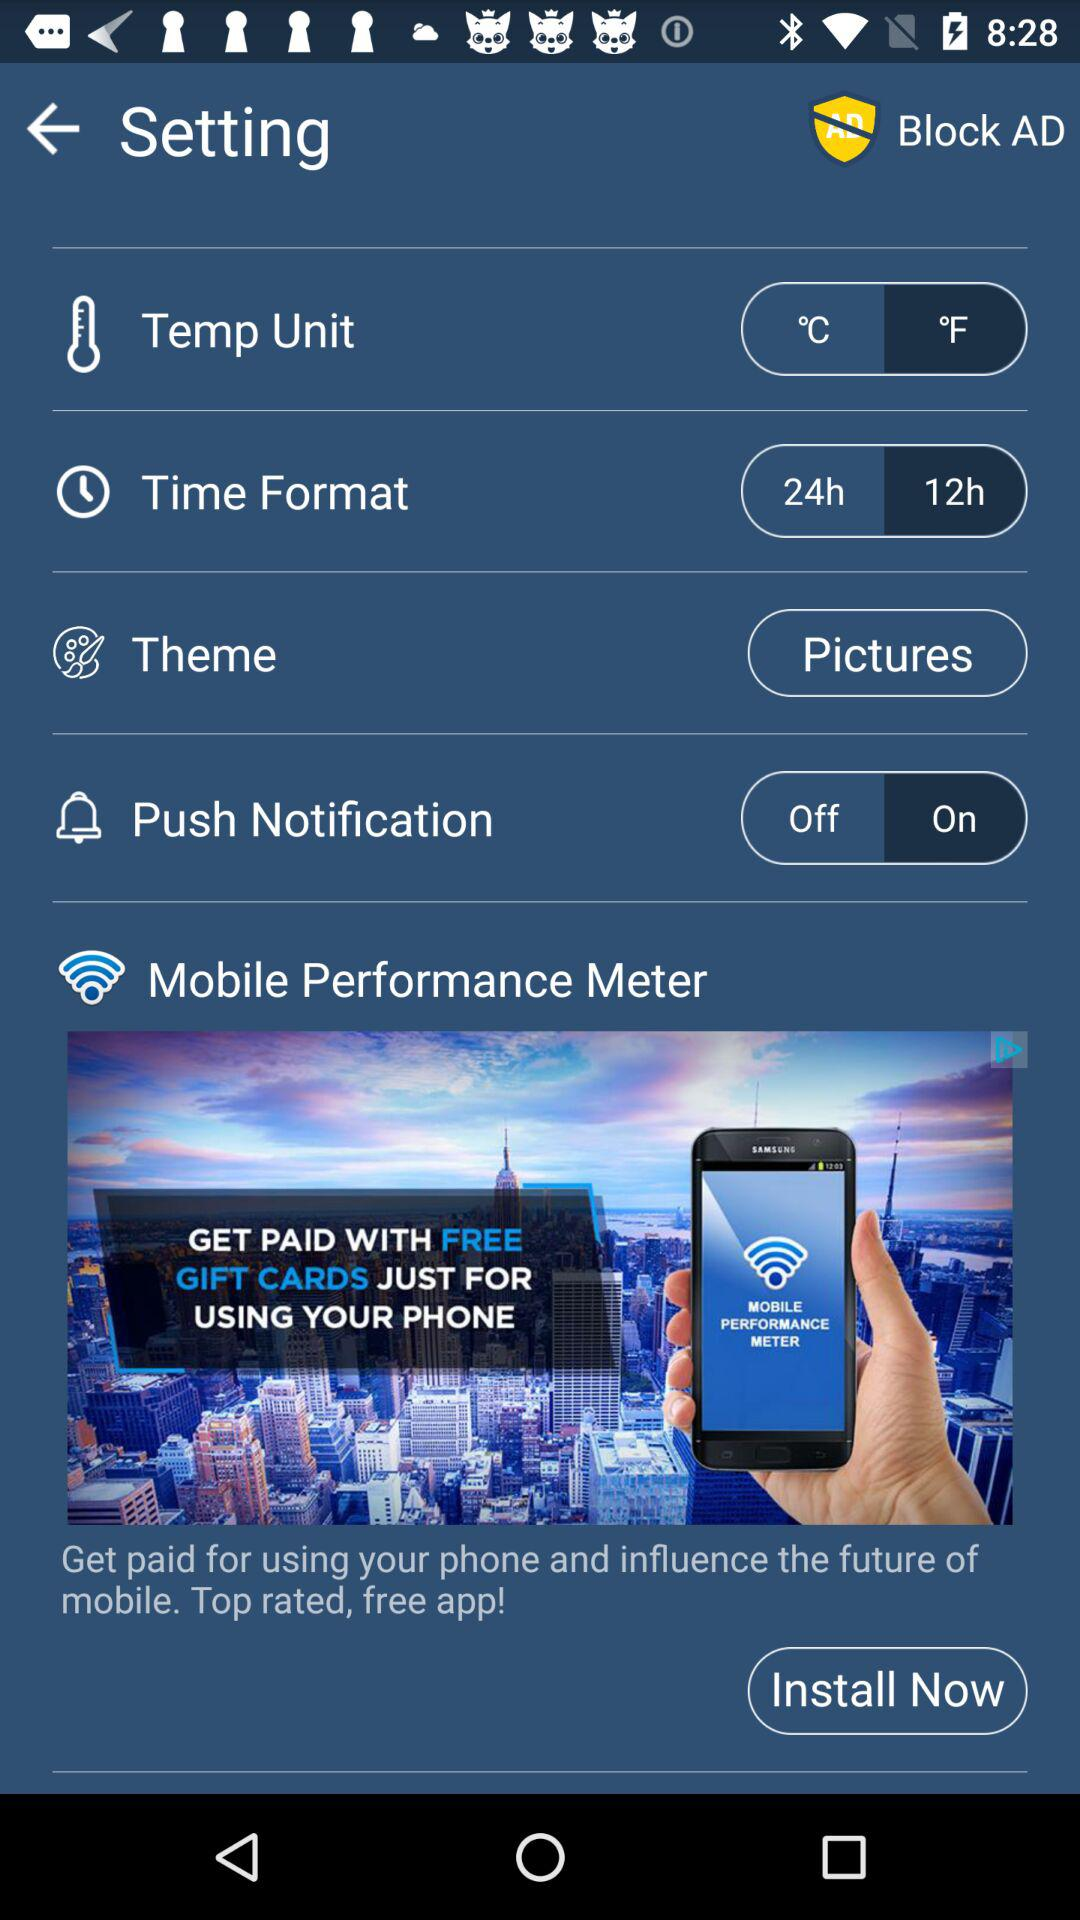What is the time format? The time format is "12h". 